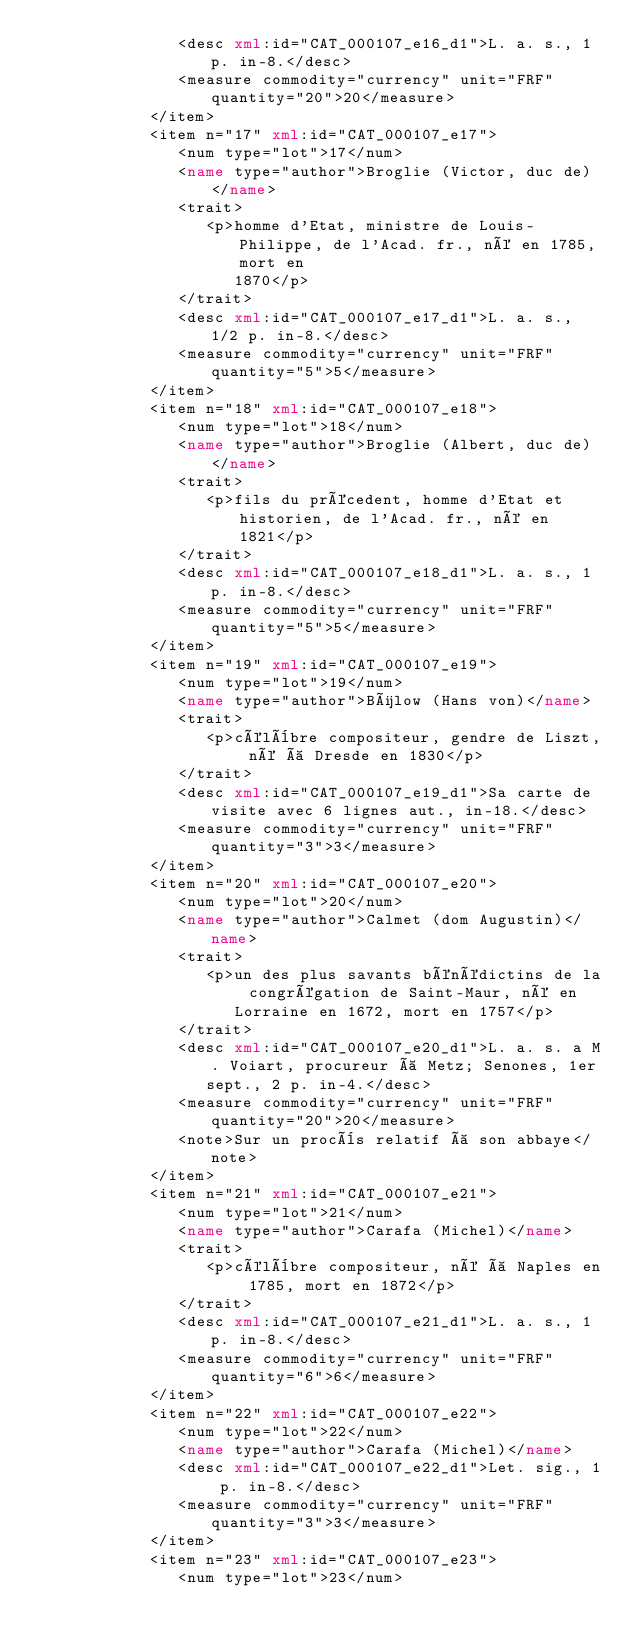Convert code to text. <code><loc_0><loc_0><loc_500><loc_500><_XML_>               <desc xml:id="CAT_000107_e16_d1">L. a. s., 1 p. in-8.</desc>
               <measure commodity="currency" unit="FRF" quantity="20">20</measure>
            </item>
            <item n="17" xml:id="CAT_000107_e17">
               <num type="lot">17</num>
               <name type="author">Broglie (Victor, duc de)</name>
               <trait>
                  <p>homme d'Etat, ministre de Louis-Philippe, de l'Acad. fr., né en 1785, mort en
                     1870</p>
               </trait>
               <desc xml:id="CAT_000107_e17_d1">L. a. s., 1/2 p. in-8.</desc>
               <measure commodity="currency" unit="FRF" quantity="5">5</measure>
            </item>
            <item n="18" xml:id="CAT_000107_e18">
               <num type="lot">18</num>
               <name type="author">Broglie (Albert, duc de)</name>
               <trait>
                  <p>fils du précedent, homme d'Etat et historien, de l'Acad. fr., né en 1821</p>
               </trait>
               <desc xml:id="CAT_000107_e18_d1">L. a. s., 1 p. in-8.</desc>
               <measure commodity="currency" unit="FRF" quantity="5">5</measure>
            </item>
            <item n="19" xml:id="CAT_000107_e19">
               <num type="lot">19</num>
               <name type="author">Bülow (Hans von)</name>
               <trait>
                  <p>célèbre compositeur, gendre de Liszt, né à Dresde en 1830</p>
               </trait>
               <desc xml:id="CAT_000107_e19_d1">Sa carte de visite avec 6 lignes aut., in-18.</desc>
               <measure commodity="currency" unit="FRF" quantity="3">3</measure>
            </item>
            <item n="20" xml:id="CAT_000107_e20">
               <num type="lot">20</num>
               <name type="author">Calmet (dom Augustin)</name>
               <trait>
                  <p>un des plus savants bénédictins de la congrégation de Saint-Maur, né en
                     Lorraine en 1672, mort en 1757</p>
               </trait>
               <desc xml:id="CAT_000107_e20_d1">L. a. s. a M. Voiart, procureur à Metz; Senones, 1er
                  sept., 2 p. in-4.</desc>
               <measure commodity="currency" unit="FRF" quantity="20">20</measure>
               <note>Sur un procès relatif à son abbaye</note>
            </item>
            <item n="21" xml:id="CAT_000107_e21">
               <num type="lot">21</num>
               <name type="author">Carafa (Michel)</name>
               <trait>
                  <p>célèbre compositeur, né à Naples en 1785, mort en 1872</p>
               </trait>
               <desc xml:id="CAT_000107_e21_d1">L. a. s., 1 p. in-8.</desc>
               <measure commodity="currency" unit="FRF" quantity="6">6</measure>
            </item>
            <item n="22" xml:id="CAT_000107_e22">
               <num type="lot">22</num>
               <name type="author">Carafa (Michel)</name>
               <desc xml:id="CAT_000107_e22_d1">Let. sig., 1 p. in-8.</desc>
               <measure commodity="currency" unit="FRF" quantity="3">3</measure>
            </item>
            <item n="23" xml:id="CAT_000107_e23">
               <num type="lot">23</num></code> 